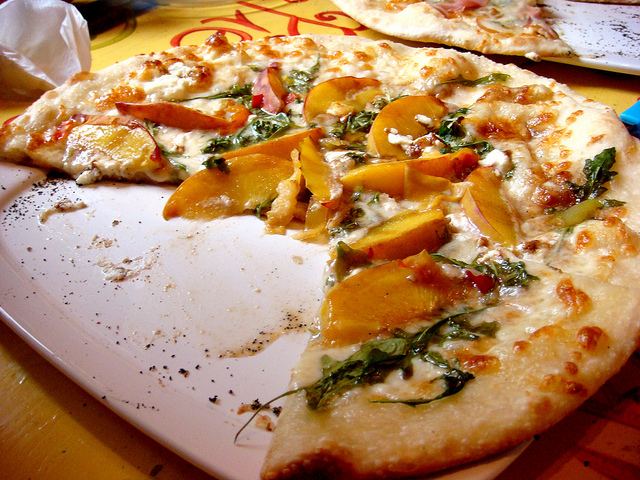What else can you infer from the image about the meal experience? The partial view of another pizza in the background and the rustic presentation suggest that this meal is enjoyed in a setting that prioritizes casual dining and comfort. The visible part of the meal, characterized by the freshness of the toppings and the artisanal look of the pizza, hints at a focus on quality ingredients and a personalized food experience. 